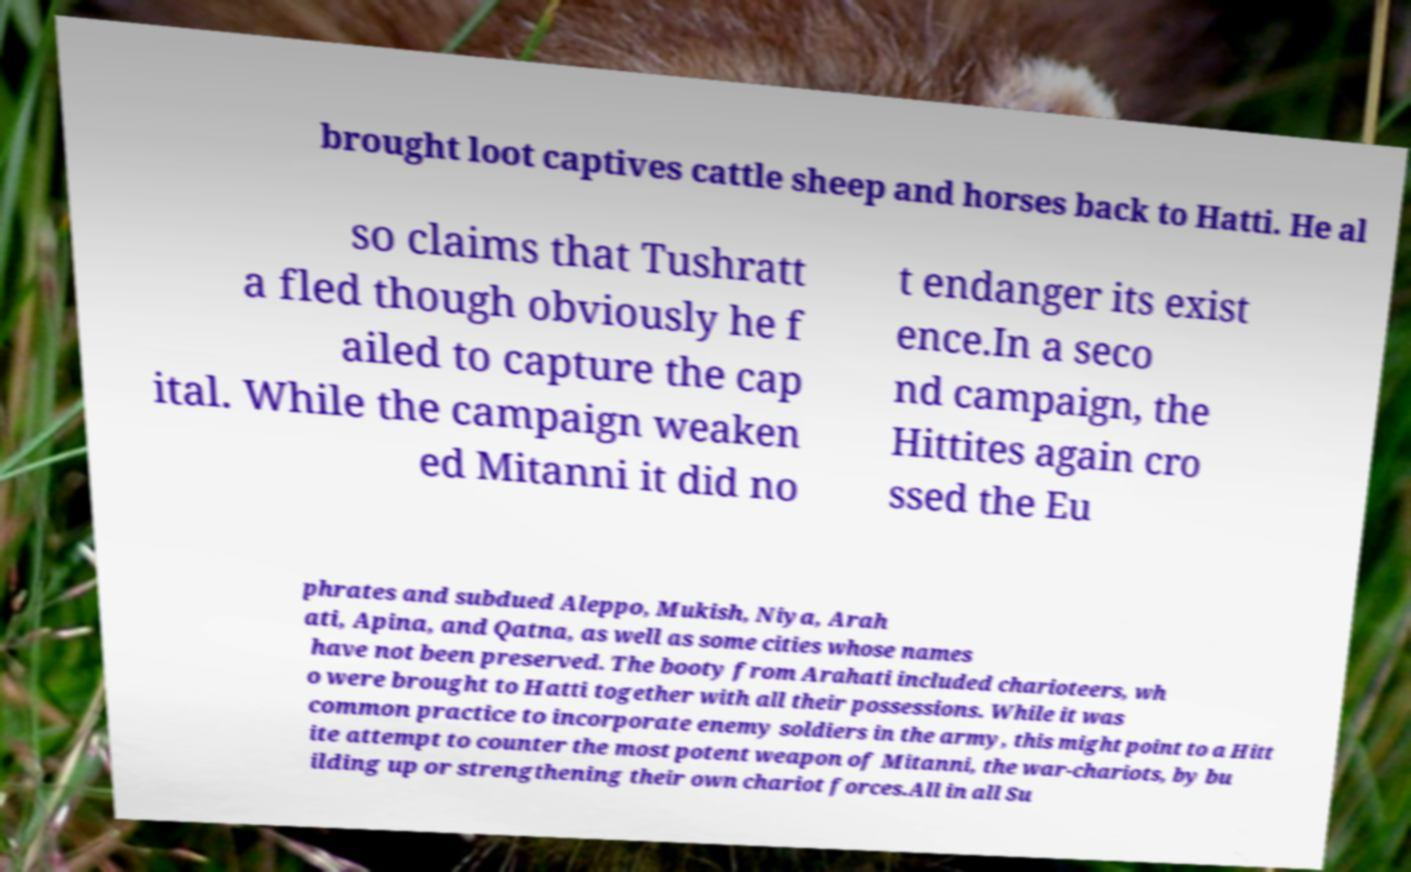Could you assist in decoding the text presented in this image and type it out clearly? brought loot captives cattle sheep and horses back to Hatti. He al so claims that Tushratt a fled though obviously he f ailed to capture the cap ital. While the campaign weaken ed Mitanni it did no t endanger its exist ence.In a seco nd campaign, the Hittites again cro ssed the Eu phrates and subdued Aleppo, Mukish, Niya, Arah ati, Apina, and Qatna, as well as some cities whose names have not been preserved. The booty from Arahati included charioteers, wh o were brought to Hatti together with all their possessions. While it was common practice to incorporate enemy soldiers in the army, this might point to a Hitt ite attempt to counter the most potent weapon of Mitanni, the war-chariots, by bu ilding up or strengthening their own chariot forces.All in all Su 